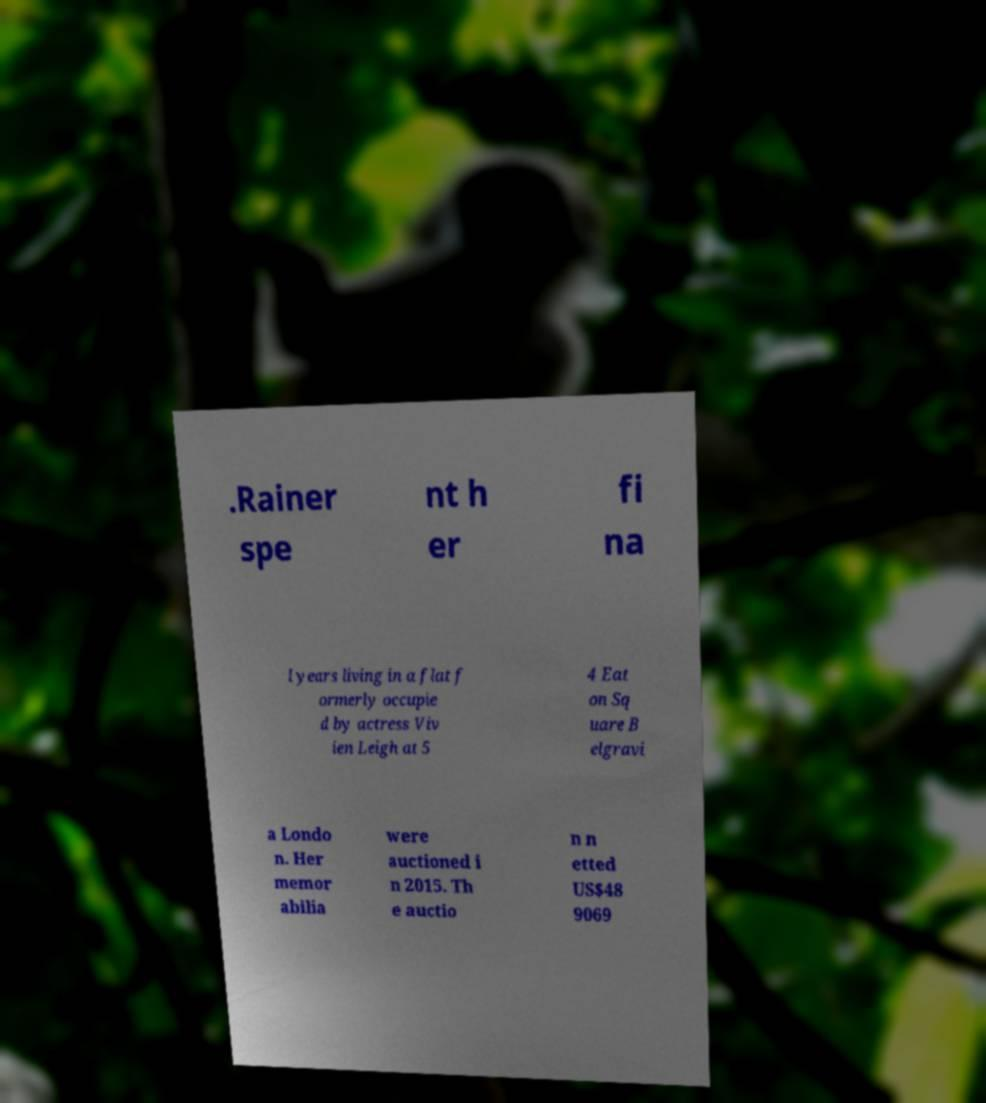There's text embedded in this image that I need extracted. Can you transcribe it verbatim? .Rainer spe nt h er fi na l years living in a flat f ormerly occupie d by actress Viv ien Leigh at 5 4 Eat on Sq uare B elgravi a Londo n. Her memor abilia were auctioned i n 2015. Th e auctio n n etted US$48 9069 